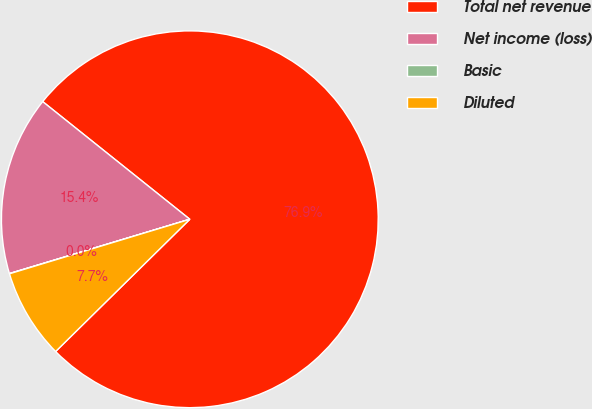Convert chart. <chart><loc_0><loc_0><loc_500><loc_500><pie_chart><fcel>Total net revenue<fcel>Net income (loss)<fcel>Basic<fcel>Diluted<nl><fcel>76.88%<fcel>15.39%<fcel>0.02%<fcel>7.71%<nl></chart> 